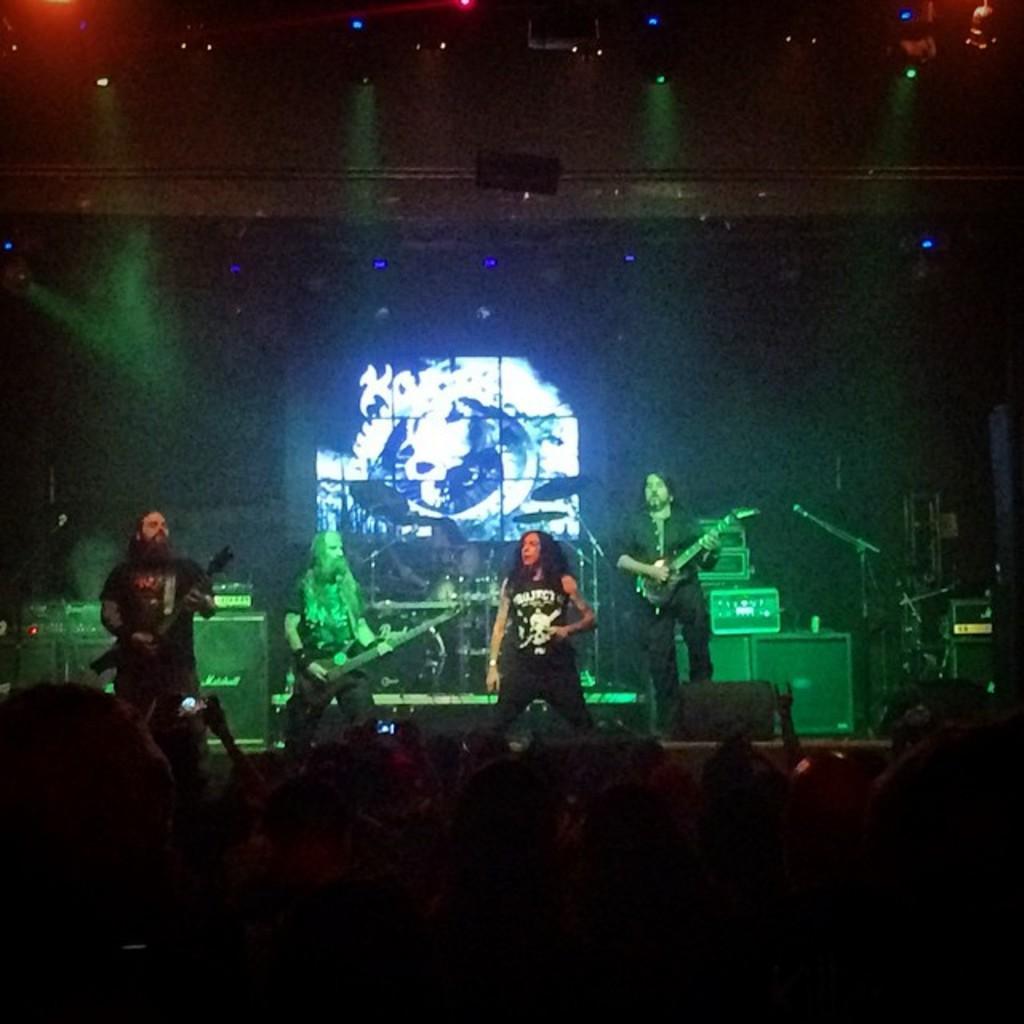Could you give a brief overview of what you see in this image? In this picture we can see a group of people where some are on stage and playing guitars and drums, mics, boxes and in the background we can see lights and it is dark. 